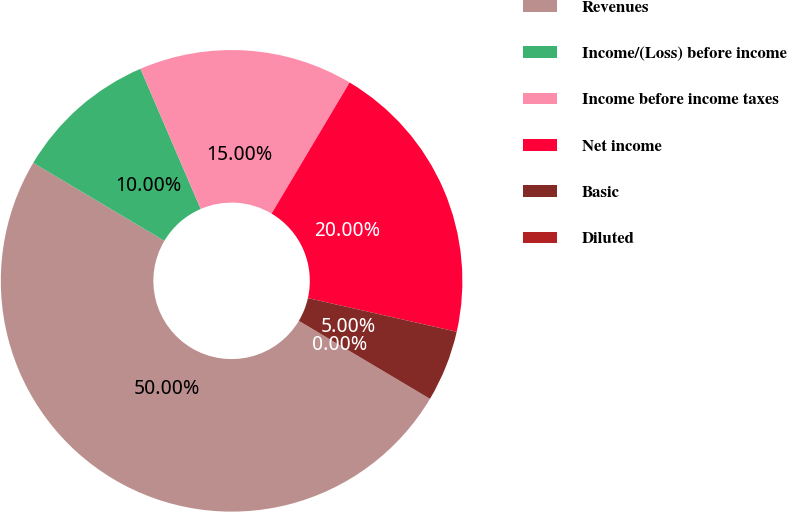<chart> <loc_0><loc_0><loc_500><loc_500><pie_chart><fcel>Revenues<fcel>Income/(Loss) before income<fcel>Income before income taxes<fcel>Net income<fcel>Basic<fcel>Diluted<nl><fcel>50.0%<fcel>10.0%<fcel>15.0%<fcel>20.0%<fcel>5.0%<fcel>0.0%<nl></chart> 